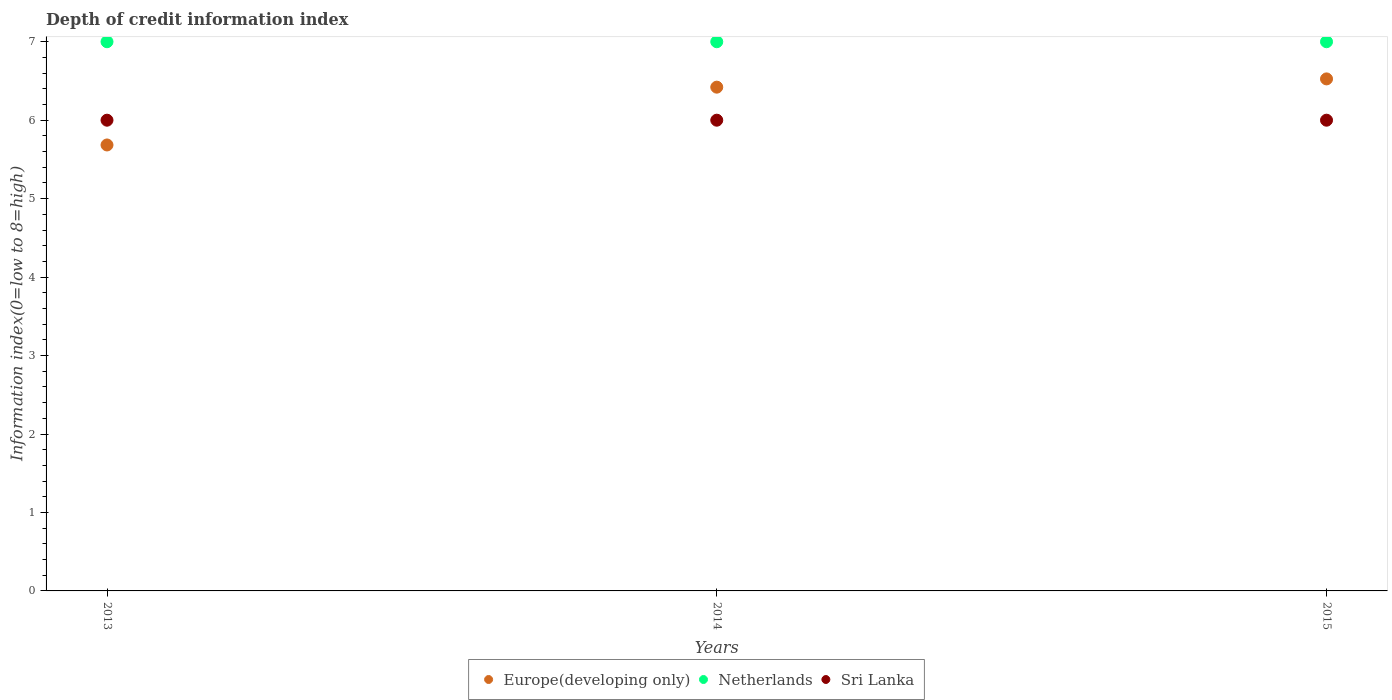How many different coloured dotlines are there?
Your response must be concise. 3. Is the number of dotlines equal to the number of legend labels?
Your answer should be very brief. Yes. What is the information index in Europe(developing only) in 2015?
Make the answer very short. 6.53. Across all years, what is the minimum information index in Europe(developing only)?
Offer a terse response. 5.68. In which year was the information index in Europe(developing only) maximum?
Your response must be concise. 2015. In which year was the information index in Netherlands minimum?
Offer a very short reply. 2013. What is the total information index in Netherlands in the graph?
Your response must be concise. 21. What is the difference between the information index in Sri Lanka in 2015 and the information index in Netherlands in 2013?
Provide a short and direct response. -1. What is the average information index in Netherlands per year?
Make the answer very short. 7. In the year 2015, what is the difference between the information index in Europe(developing only) and information index in Netherlands?
Give a very brief answer. -0.47. In how many years, is the information index in Sri Lanka greater than 0.8?
Offer a terse response. 3. Is the information index in Sri Lanka in 2013 less than that in 2014?
Provide a succinct answer. No. What is the difference between the highest and the second highest information index in Europe(developing only)?
Your response must be concise. 0.11. Is it the case that in every year, the sum of the information index in Sri Lanka and information index in Europe(developing only)  is greater than the information index in Netherlands?
Offer a terse response. Yes. Is the information index in Europe(developing only) strictly greater than the information index in Netherlands over the years?
Keep it short and to the point. No. How many years are there in the graph?
Give a very brief answer. 3. Are the values on the major ticks of Y-axis written in scientific E-notation?
Ensure brevity in your answer.  No. Does the graph contain any zero values?
Offer a terse response. No. Does the graph contain grids?
Your answer should be very brief. No. Where does the legend appear in the graph?
Offer a terse response. Bottom center. How are the legend labels stacked?
Your response must be concise. Horizontal. What is the title of the graph?
Your response must be concise. Depth of credit information index. What is the label or title of the X-axis?
Make the answer very short. Years. What is the label or title of the Y-axis?
Give a very brief answer. Information index(0=low to 8=high). What is the Information index(0=low to 8=high) of Europe(developing only) in 2013?
Offer a very short reply. 5.68. What is the Information index(0=low to 8=high) of Netherlands in 2013?
Provide a short and direct response. 7. What is the Information index(0=low to 8=high) in Europe(developing only) in 2014?
Keep it short and to the point. 6.42. What is the Information index(0=low to 8=high) in Netherlands in 2014?
Give a very brief answer. 7. What is the Information index(0=low to 8=high) in Europe(developing only) in 2015?
Ensure brevity in your answer.  6.53. What is the Information index(0=low to 8=high) in Sri Lanka in 2015?
Offer a very short reply. 6. Across all years, what is the maximum Information index(0=low to 8=high) of Europe(developing only)?
Ensure brevity in your answer.  6.53. Across all years, what is the maximum Information index(0=low to 8=high) of Netherlands?
Provide a short and direct response. 7. Across all years, what is the maximum Information index(0=low to 8=high) in Sri Lanka?
Keep it short and to the point. 6. Across all years, what is the minimum Information index(0=low to 8=high) in Europe(developing only)?
Your answer should be very brief. 5.68. Across all years, what is the minimum Information index(0=low to 8=high) in Sri Lanka?
Give a very brief answer. 6. What is the total Information index(0=low to 8=high) of Europe(developing only) in the graph?
Offer a very short reply. 18.63. What is the total Information index(0=low to 8=high) in Netherlands in the graph?
Offer a terse response. 21. What is the total Information index(0=low to 8=high) of Sri Lanka in the graph?
Your response must be concise. 18. What is the difference between the Information index(0=low to 8=high) of Europe(developing only) in 2013 and that in 2014?
Ensure brevity in your answer.  -0.74. What is the difference between the Information index(0=low to 8=high) of Sri Lanka in 2013 and that in 2014?
Make the answer very short. 0. What is the difference between the Information index(0=low to 8=high) of Europe(developing only) in 2013 and that in 2015?
Provide a short and direct response. -0.84. What is the difference between the Information index(0=low to 8=high) of Sri Lanka in 2013 and that in 2015?
Your answer should be very brief. 0. What is the difference between the Information index(0=low to 8=high) in Europe(developing only) in 2014 and that in 2015?
Your response must be concise. -0.11. What is the difference between the Information index(0=low to 8=high) of Europe(developing only) in 2013 and the Information index(0=low to 8=high) of Netherlands in 2014?
Ensure brevity in your answer.  -1.32. What is the difference between the Information index(0=low to 8=high) of Europe(developing only) in 2013 and the Information index(0=low to 8=high) of Sri Lanka in 2014?
Your response must be concise. -0.32. What is the difference between the Information index(0=low to 8=high) of Netherlands in 2013 and the Information index(0=low to 8=high) of Sri Lanka in 2014?
Your response must be concise. 1. What is the difference between the Information index(0=low to 8=high) in Europe(developing only) in 2013 and the Information index(0=low to 8=high) in Netherlands in 2015?
Your answer should be compact. -1.32. What is the difference between the Information index(0=low to 8=high) of Europe(developing only) in 2013 and the Information index(0=low to 8=high) of Sri Lanka in 2015?
Your answer should be very brief. -0.32. What is the difference between the Information index(0=low to 8=high) in Europe(developing only) in 2014 and the Information index(0=low to 8=high) in Netherlands in 2015?
Make the answer very short. -0.58. What is the difference between the Information index(0=low to 8=high) of Europe(developing only) in 2014 and the Information index(0=low to 8=high) of Sri Lanka in 2015?
Make the answer very short. 0.42. What is the average Information index(0=low to 8=high) in Europe(developing only) per year?
Offer a terse response. 6.21. What is the average Information index(0=low to 8=high) in Netherlands per year?
Ensure brevity in your answer.  7. What is the average Information index(0=low to 8=high) in Sri Lanka per year?
Your answer should be compact. 6. In the year 2013, what is the difference between the Information index(0=low to 8=high) in Europe(developing only) and Information index(0=low to 8=high) in Netherlands?
Provide a short and direct response. -1.32. In the year 2013, what is the difference between the Information index(0=low to 8=high) of Europe(developing only) and Information index(0=low to 8=high) of Sri Lanka?
Keep it short and to the point. -0.32. In the year 2014, what is the difference between the Information index(0=low to 8=high) in Europe(developing only) and Information index(0=low to 8=high) in Netherlands?
Offer a very short reply. -0.58. In the year 2014, what is the difference between the Information index(0=low to 8=high) in Europe(developing only) and Information index(0=low to 8=high) in Sri Lanka?
Keep it short and to the point. 0.42. In the year 2015, what is the difference between the Information index(0=low to 8=high) of Europe(developing only) and Information index(0=low to 8=high) of Netherlands?
Provide a short and direct response. -0.47. In the year 2015, what is the difference between the Information index(0=low to 8=high) of Europe(developing only) and Information index(0=low to 8=high) of Sri Lanka?
Make the answer very short. 0.53. In the year 2015, what is the difference between the Information index(0=low to 8=high) of Netherlands and Information index(0=low to 8=high) of Sri Lanka?
Offer a very short reply. 1. What is the ratio of the Information index(0=low to 8=high) in Europe(developing only) in 2013 to that in 2014?
Your response must be concise. 0.89. What is the ratio of the Information index(0=low to 8=high) in Sri Lanka in 2013 to that in 2014?
Make the answer very short. 1. What is the ratio of the Information index(0=low to 8=high) of Europe(developing only) in 2013 to that in 2015?
Give a very brief answer. 0.87. What is the ratio of the Information index(0=low to 8=high) of Netherlands in 2013 to that in 2015?
Give a very brief answer. 1. What is the ratio of the Information index(0=low to 8=high) in Sri Lanka in 2013 to that in 2015?
Provide a succinct answer. 1. What is the ratio of the Information index(0=low to 8=high) in Europe(developing only) in 2014 to that in 2015?
Keep it short and to the point. 0.98. What is the ratio of the Information index(0=low to 8=high) in Sri Lanka in 2014 to that in 2015?
Make the answer very short. 1. What is the difference between the highest and the second highest Information index(0=low to 8=high) in Europe(developing only)?
Your answer should be very brief. 0.11. What is the difference between the highest and the lowest Information index(0=low to 8=high) in Europe(developing only)?
Offer a very short reply. 0.84. What is the difference between the highest and the lowest Information index(0=low to 8=high) in Netherlands?
Offer a very short reply. 0. What is the difference between the highest and the lowest Information index(0=low to 8=high) of Sri Lanka?
Your answer should be compact. 0. 